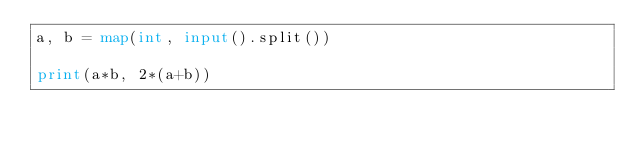<code> <loc_0><loc_0><loc_500><loc_500><_Python_>a, b = map(int, input().split())

print(a*b, 2*(a+b))
</code> 